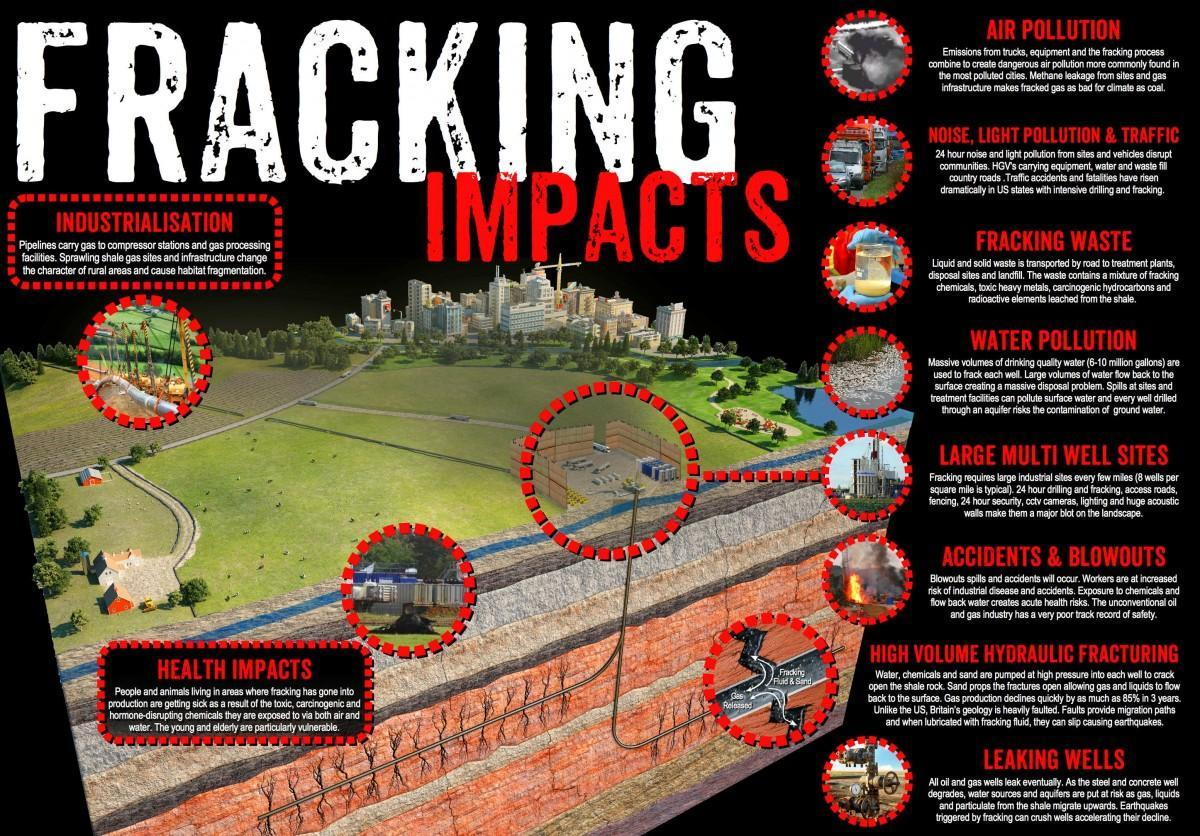How many types of pollution are caused due to fracking?
Answer the question with a short phrase. 4 